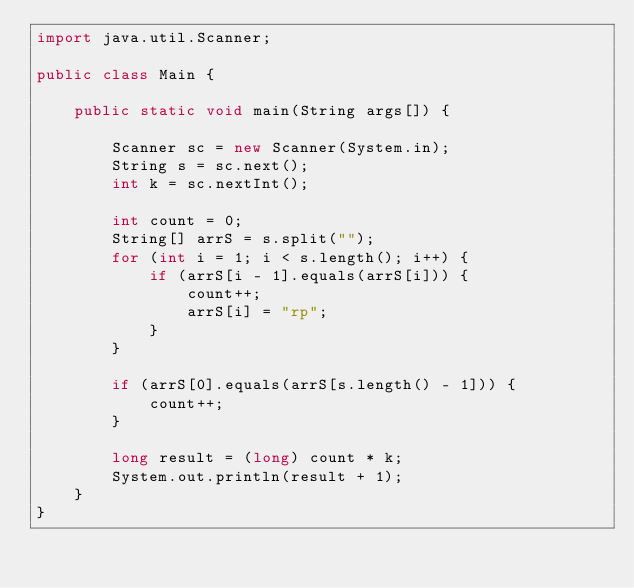<code> <loc_0><loc_0><loc_500><loc_500><_Java_>import java.util.Scanner;

public class Main {

    public static void main(String args[]) {

        Scanner sc = new Scanner(System.in);
        String s = sc.next();
        int k = sc.nextInt();

        int count = 0;
        String[] arrS = s.split("");
        for (int i = 1; i < s.length(); i++) {
            if (arrS[i - 1].equals(arrS[i])) {
                count++;
                arrS[i] = "rp";
            }
        }

        if (arrS[0].equals(arrS[s.length() - 1])) {
            count++;
        }

        long result = (long) count * k;
        System.out.println(result + 1);
    }
}
</code> 